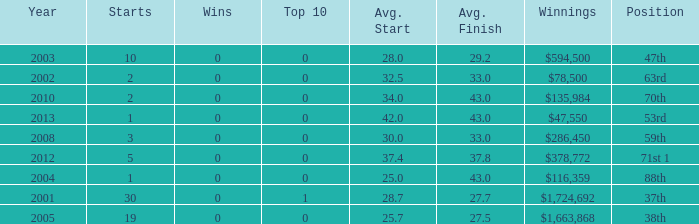How many wins for average start less than 25? 0.0. 